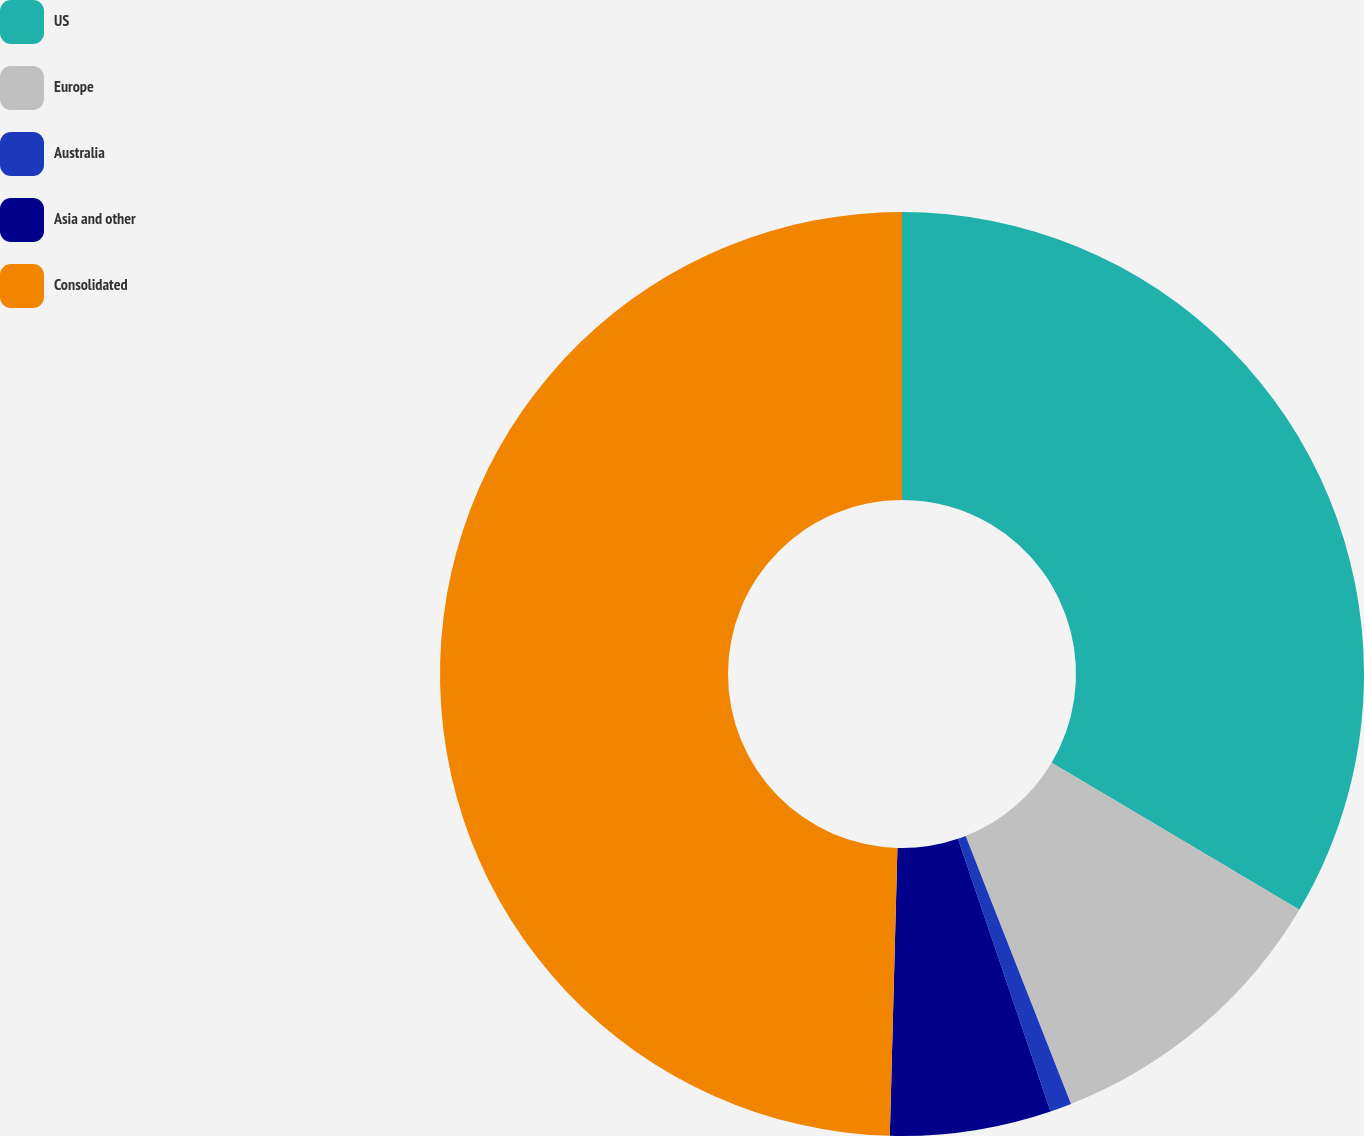<chart> <loc_0><loc_0><loc_500><loc_500><pie_chart><fcel>US<fcel>Europe<fcel>Australia<fcel>Asia and other<fcel>Consolidated<nl><fcel>33.52%<fcel>10.52%<fcel>0.75%<fcel>5.63%<fcel>49.58%<nl></chart> 